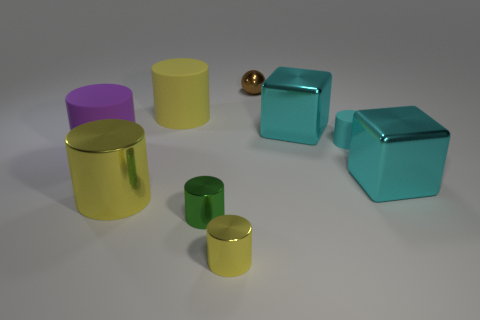There is a matte cylinder that is the same color as the large metallic cylinder; what is its size?
Give a very brief answer. Large. What is the tiny brown thing made of?
Ensure brevity in your answer.  Metal. Is the cube left of the tiny matte cylinder made of the same material as the big purple thing?
Offer a terse response. No. Are there fewer tiny cyan matte objects that are in front of the green shiny cylinder than red things?
Your answer should be compact. No. There is a rubber object that is the same size as the ball; what color is it?
Your answer should be very brief. Cyan. What number of metal things are the same shape as the yellow matte object?
Keep it short and to the point. 3. What is the color of the large rubber thing to the right of the purple rubber cylinder?
Your answer should be very brief. Yellow. What number of metallic objects are cylinders or small cyan cylinders?
Provide a short and direct response. 3. There is a big object that is the same color as the big metallic cylinder; what shape is it?
Provide a succinct answer. Cylinder. What number of cyan rubber things have the same size as the yellow matte thing?
Make the answer very short. 0. 